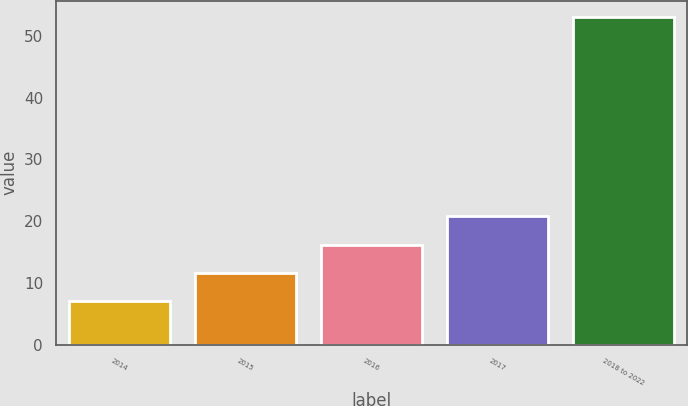Convert chart. <chart><loc_0><loc_0><loc_500><loc_500><bar_chart><fcel>2014<fcel>2015<fcel>2016<fcel>2017<fcel>2018 to 2022<nl><fcel>7<fcel>11.6<fcel>16.2<fcel>20.8<fcel>53<nl></chart> 